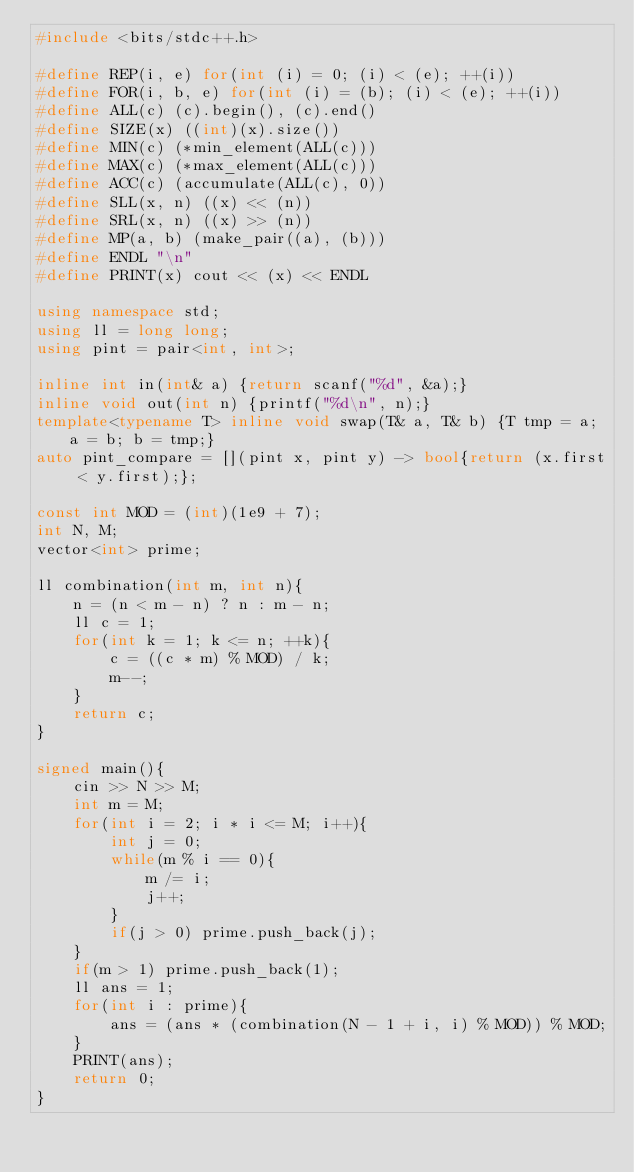Convert code to text. <code><loc_0><loc_0><loc_500><loc_500><_C++_>#include <bits/stdc++.h>

#define REP(i, e) for(int (i) = 0; (i) < (e); ++(i))
#define FOR(i, b, e) for(int (i) = (b); (i) < (e); ++(i))
#define ALL(c) (c).begin(), (c).end()
#define SIZE(x) ((int)(x).size())
#define MIN(c) (*min_element(ALL(c))) 
#define MAX(c) (*max_element(ALL(c)))
#define ACC(c) (accumulate(ALL(c), 0))
#define SLL(x, n) ((x) << (n))
#define SRL(x, n) ((x) >> (n))
#define MP(a, b) (make_pair((a), (b)))
#define ENDL "\n"
#define PRINT(x) cout << (x) << ENDL

using namespace std;
using ll = long long;
using pint = pair<int, int>;

inline int in(int& a) {return scanf("%d", &a);}
inline void out(int n) {printf("%d\n", n);}
template<typename T> inline void swap(T& a, T& b) {T tmp = a; a = b; b = tmp;}
auto pint_compare = [](pint x, pint y) -> bool{return (x.first < y.first);};

const int MOD = (int)(1e9 + 7);
int N, M;
vector<int> prime;

ll combination(int m, int n){
    n = (n < m - n) ? n : m - n;
    ll c = 1;
    for(int k = 1; k <= n; ++k){
        c = ((c * m) % MOD) / k;
        m--;
    }
    return c;
}

signed main(){
    cin >> N >> M;
    int m = M;
    for(int i = 2; i * i <= M; i++){
        int j = 0;
        while(m % i == 0){
            m /= i;
            j++;
        }
        if(j > 0) prime.push_back(j);
    }
    if(m > 1) prime.push_back(1);
    ll ans = 1;
    for(int i : prime){
        ans = (ans * (combination(N - 1 + i, i) % MOD)) % MOD;
    }
    PRINT(ans);
    return 0;
}</code> 